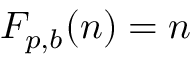Convert formula to latex. <formula><loc_0><loc_0><loc_500><loc_500>F _ { p , b } ( n ) = n</formula> 